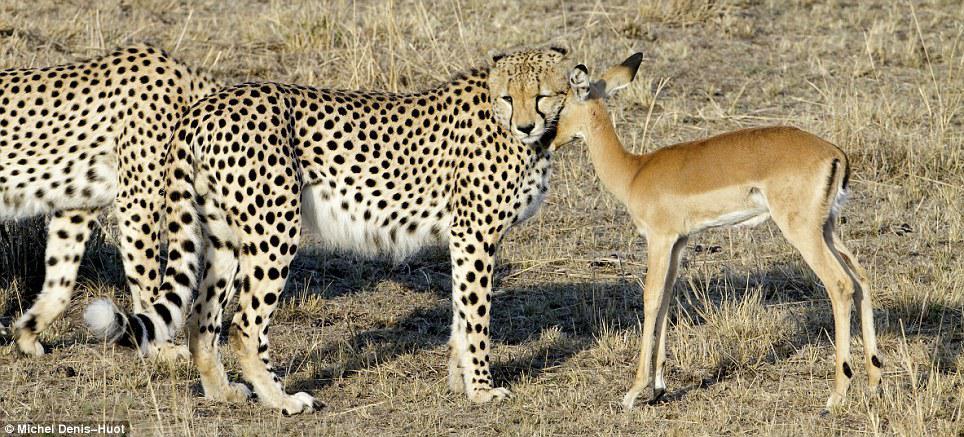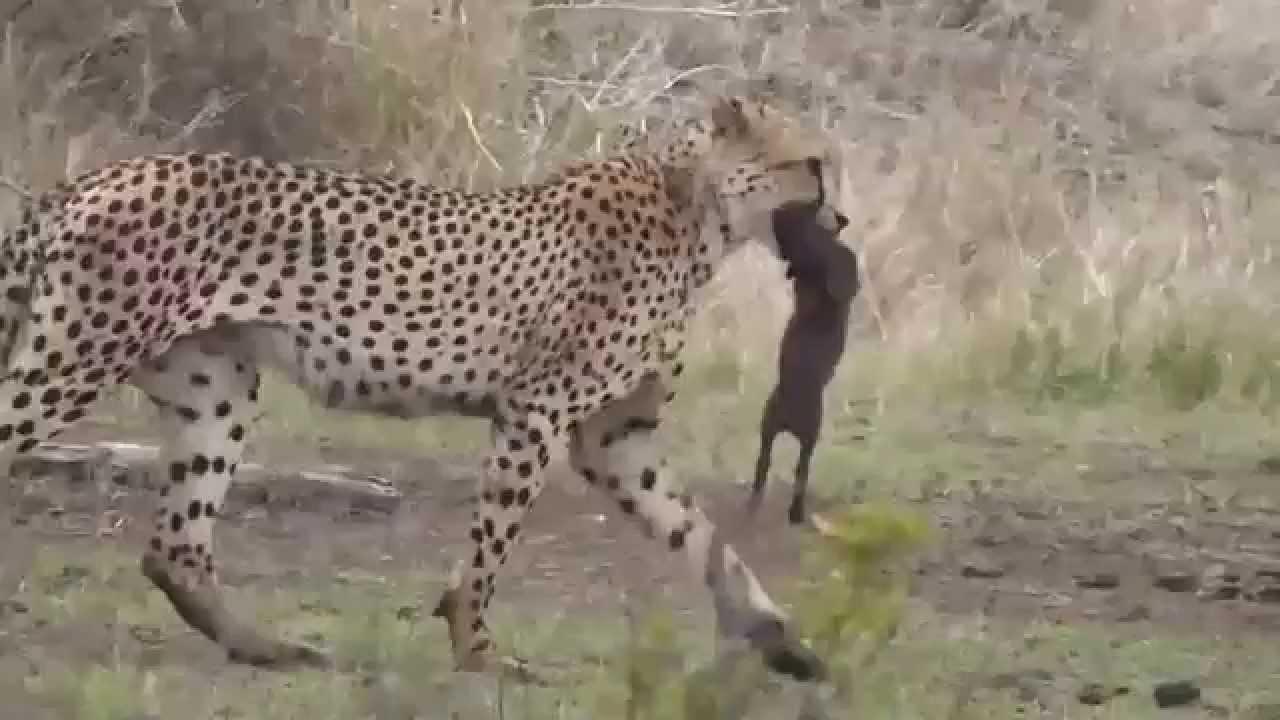The first image is the image on the left, the second image is the image on the right. For the images shown, is this caption "contains a picture of a cheetah carrying its food" true? Answer yes or no. Yes. The first image is the image on the left, the second image is the image on the right. Evaluate the accuracy of this statement regarding the images: "One image shows two cheetahs posing non-agressively with a small deerlike animal, and the other shows a cheetah with its prey grasped in its jaw.". Is it true? Answer yes or no. Yes. 